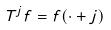<formula> <loc_0><loc_0><loc_500><loc_500>T ^ { j } f = f ( \cdot + j )</formula> 